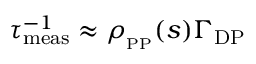<formula> <loc_0><loc_0><loc_500><loc_500>\tau _ { m e a s } ^ { - 1 } \approx \rho _ { _ { P P } } ( s ) \Gamma _ { D P }</formula> 